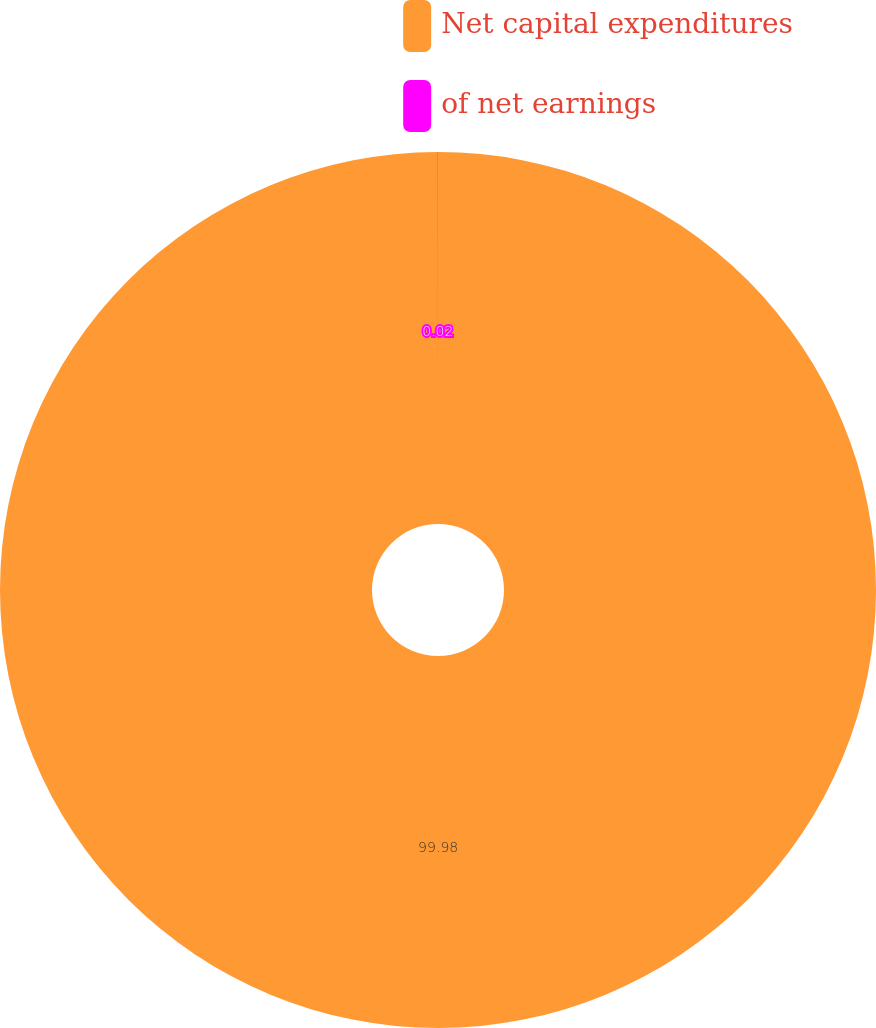Convert chart to OTSL. <chart><loc_0><loc_0><loc_500><loc_500><pie_chart><fcel>Net capital expenditures<fcel>of net earnings<nl><fcel>99.98%<fcel>0.02%<nl></chart> 